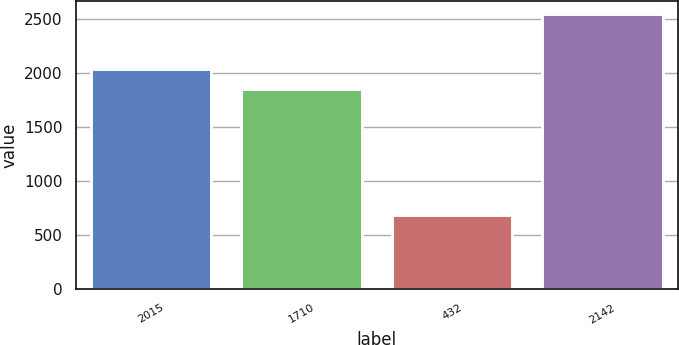<chart> <loc_0><loc_0><loc_500><loc_500><bar_chart><fcel>2015<fcel>1710<fcel>432<fcel>2142<nl><fcel>2043.8<fcel>1858<fcel>689<fcel>2547<nl></chart> 